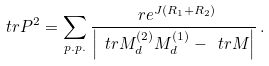<formula> <loc_0><loc_0><loc_500><loc_500>\ t r P ^ { 2 } = \sum _ { p . p . } \frac { \ r e ^ { J ( R _ { 1 } + R _ { 2 } ) } } { \left | \ t r M _ { d } ^ { ( 2 ) } M _ { d } ^ { ( 1 ) } - \ t r M \right | } \, .</formula> 